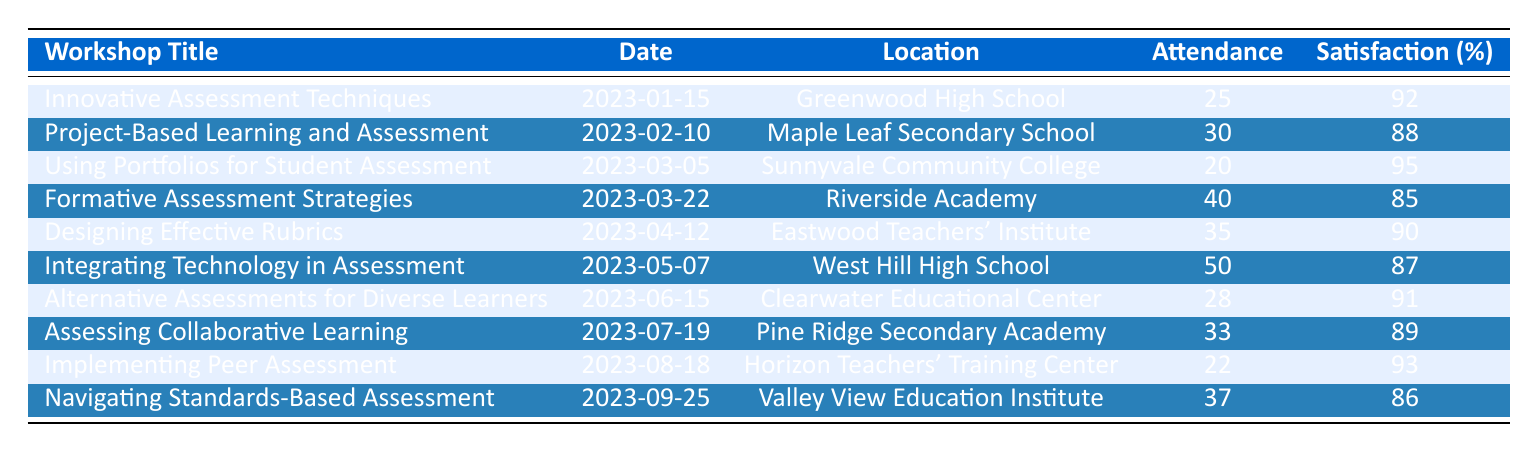What was the location of the workshop "Designing Effective Rubrics"? According to the table, the location for "Designing Effective Rubrics" is listed as "Eastwood Teachers' Institute".
Answer: Eastwood Teachers' Institute How many attendees were present at the workshop "Using Portfolios for Student Assessment"? The table specifies that the attendance for "Using Portfolios for Student Assessment" was recorded as 20.
Answer: 20 What is the satisfaction rate for the "Formative Assessment Strategies" workshop? The workshop "Formative Assessment Strategies" has a satisfaction rate noted as 85% in the table.
Answer: 85% Which workshop had the highest satisfaction rate and what was that rate? By comparing the satisfaction rates in the table, "Using Portfolios for Student Assessment" has the highest satisfaction rate at 95%.
Answer: 95% What is the average attendance across all workshops? To find the average attendance, sum the attendance numbers (25 + 30 + 20 + 40 + 35 + 50 + 28 + 33 + 22 + 37 =  400) and divide by the total number of workshops (10). The average is 400/10 = 40.
Answer: 40 How many workshops had an attendance of more than 30? From the table, the workshops with attendance greater than 30 are "Project-Based Learning and Assessment" (30), "Formative Assessment Strategies" (40), "Designing Effective Rubrics" (35), "Integrating Technology in Assessment" (50), "Assessing Collaborative Learning" (33), and "Navigating Standards-Based Assessment" (37) totaling 6 workshops.
Answer: 6 Is the satisfaction rate for "Integrating Technology in Assessment" higher or lower than 90%? The table shows the satisfaction rate for this workshop is 87%, which is lower than 90%.
Answer: Lower What is the difference in satisfaction rates between the "Alternative Assessments for Diverse Learners" and "Formative Assessment Strategies" workshops? The satisfaction rate for "Alternative Assessments for Diverse Learners" is 91% and for "Formative Assessment Strategies" is 85%. The difference is 91 - 85 = 6.
Answer: 6 Which workshop had more than 30 attendees and a satisfaction rate below 90%? The only workshop fitting this criterion is "Formative Assessment Strategies" with 40 attendees and a satisfaction rate of 85%.
Answer: Formative Assessment Strategies How many workshops took place in the first half of the year? By checking the dates, there are 6 workshops (January, February, March, April, May, June) that took place in the first half of the year.
Answer: 6 What proportion of workshops had a satisfaction rate above 90%? The workshops with satisfaction rates above 90% are "Innovative Assessment Techniques" (92), "Using Portfolios for Student Assessment" (95), "Implementing Peer Assessment" (93), and "Alternative Assessments for Diverse Learners" (91). There are 4 workshops out of 10, so the proportion is 4/10 or 40%.
Answer: 40% 